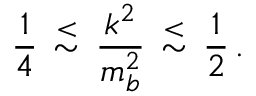Convert formula to latex. <formula><loc_0><loc_0><loc_500><loc_500>\frac { 1 } { 4 } \, { \stackrel { < } { \sim } } \, \frac { k ^ { 2 } } { m _ { b } ^ { 2 } } \, { \stackrel { < } { \sim } } \, \frac { 1 } { 2 } \, .</formula> 